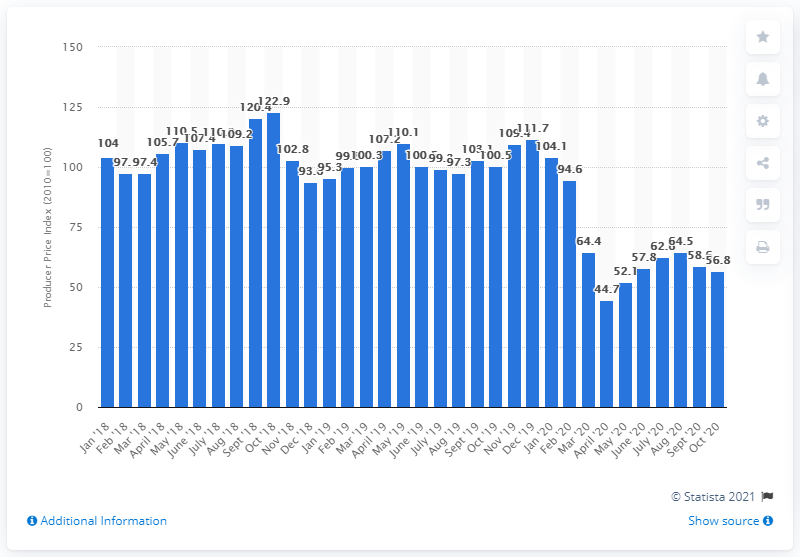Outline some significant characteristics in this image. In April 2020, the PPI score for the mining sector was 44.7. 